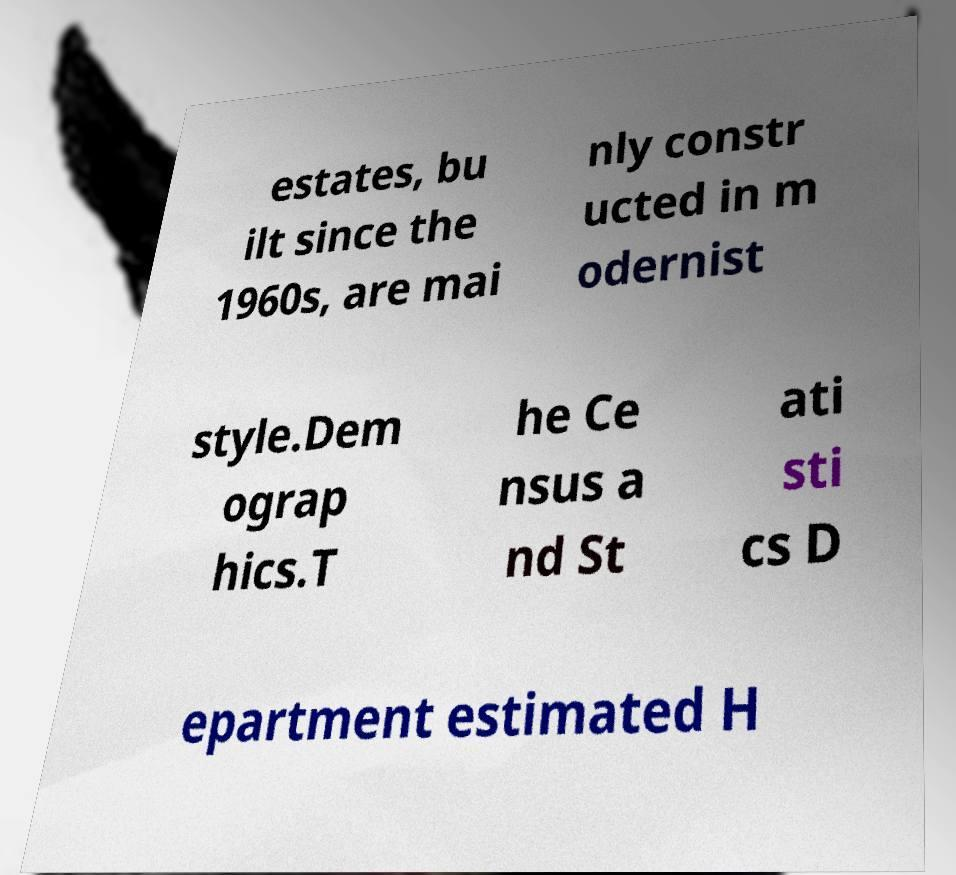There's text embedded in this image that I need extracted. Can you transcribe it verbatim? estates, bu ilt since the 1960s, are mai nly constr ucted in m odernist style.Dem ograp hics.T he Ce nsus a nd St ati sti cs D epartment estimated H 